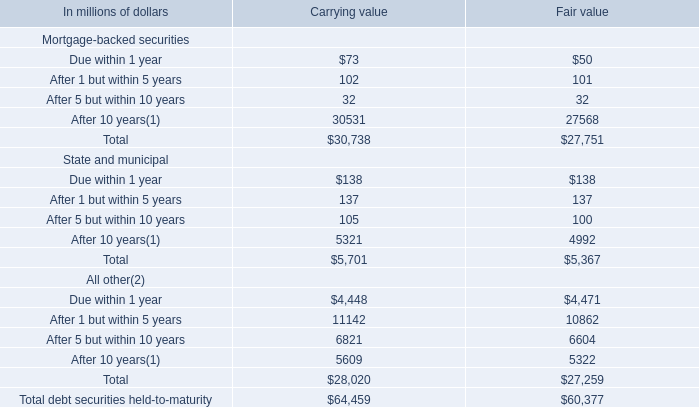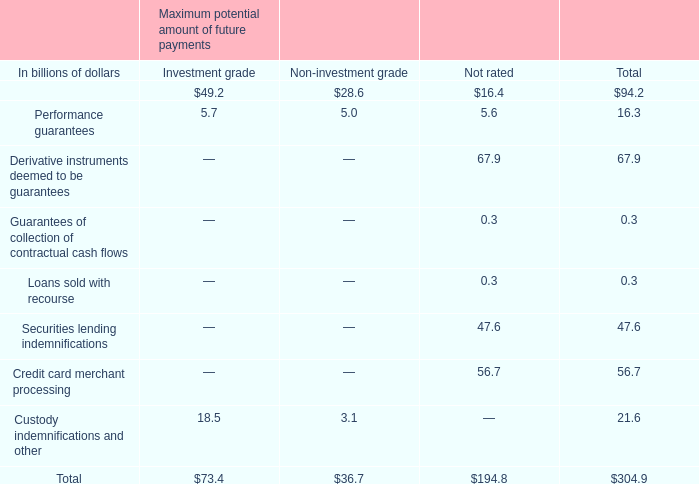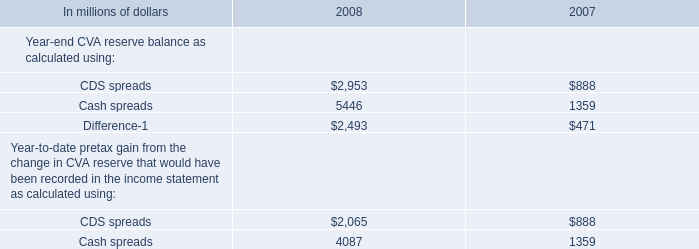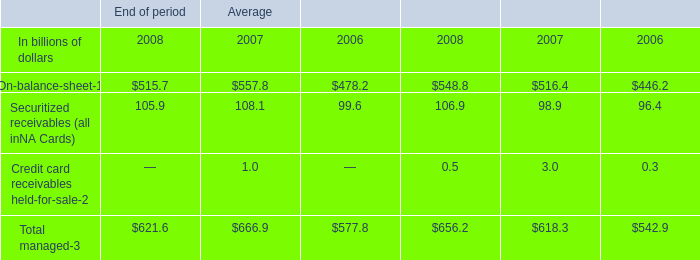What is the sum of Difference in 2007 and Total debt securities held-to-maturity for Fair value? (in million) 
Computations: (471 + 60377)
Answer: 60848.0. 